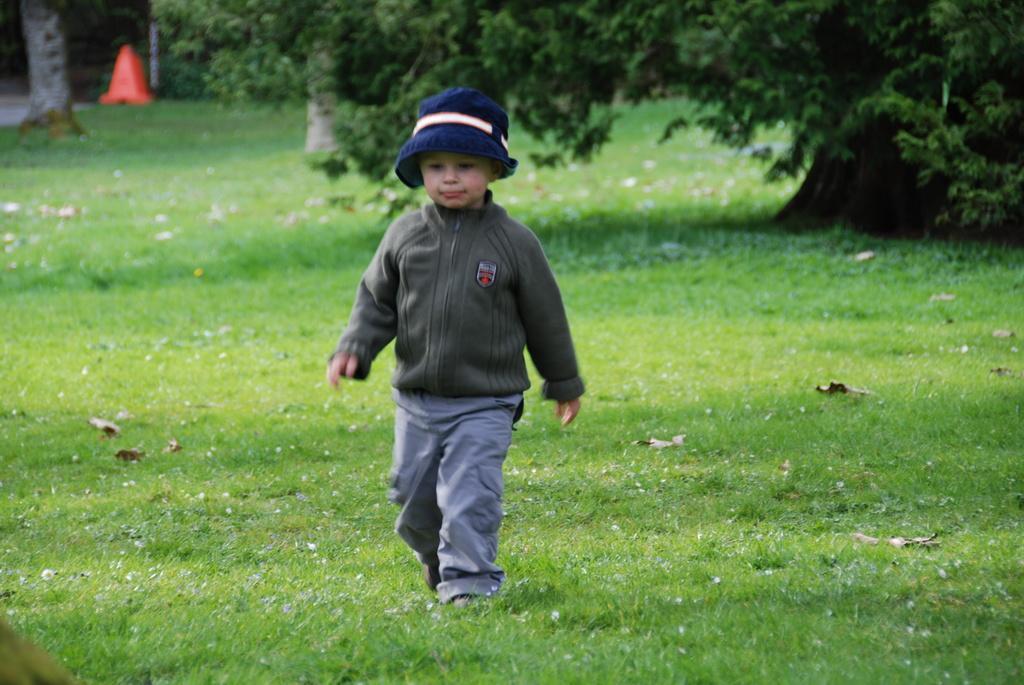Please provide a concise description of this image. In this picture, we can see a child on the ground, we can see the ground with grass, trees, and we can see some dry leaves on the ground, we can see orange color object on the top left side of the picture. 